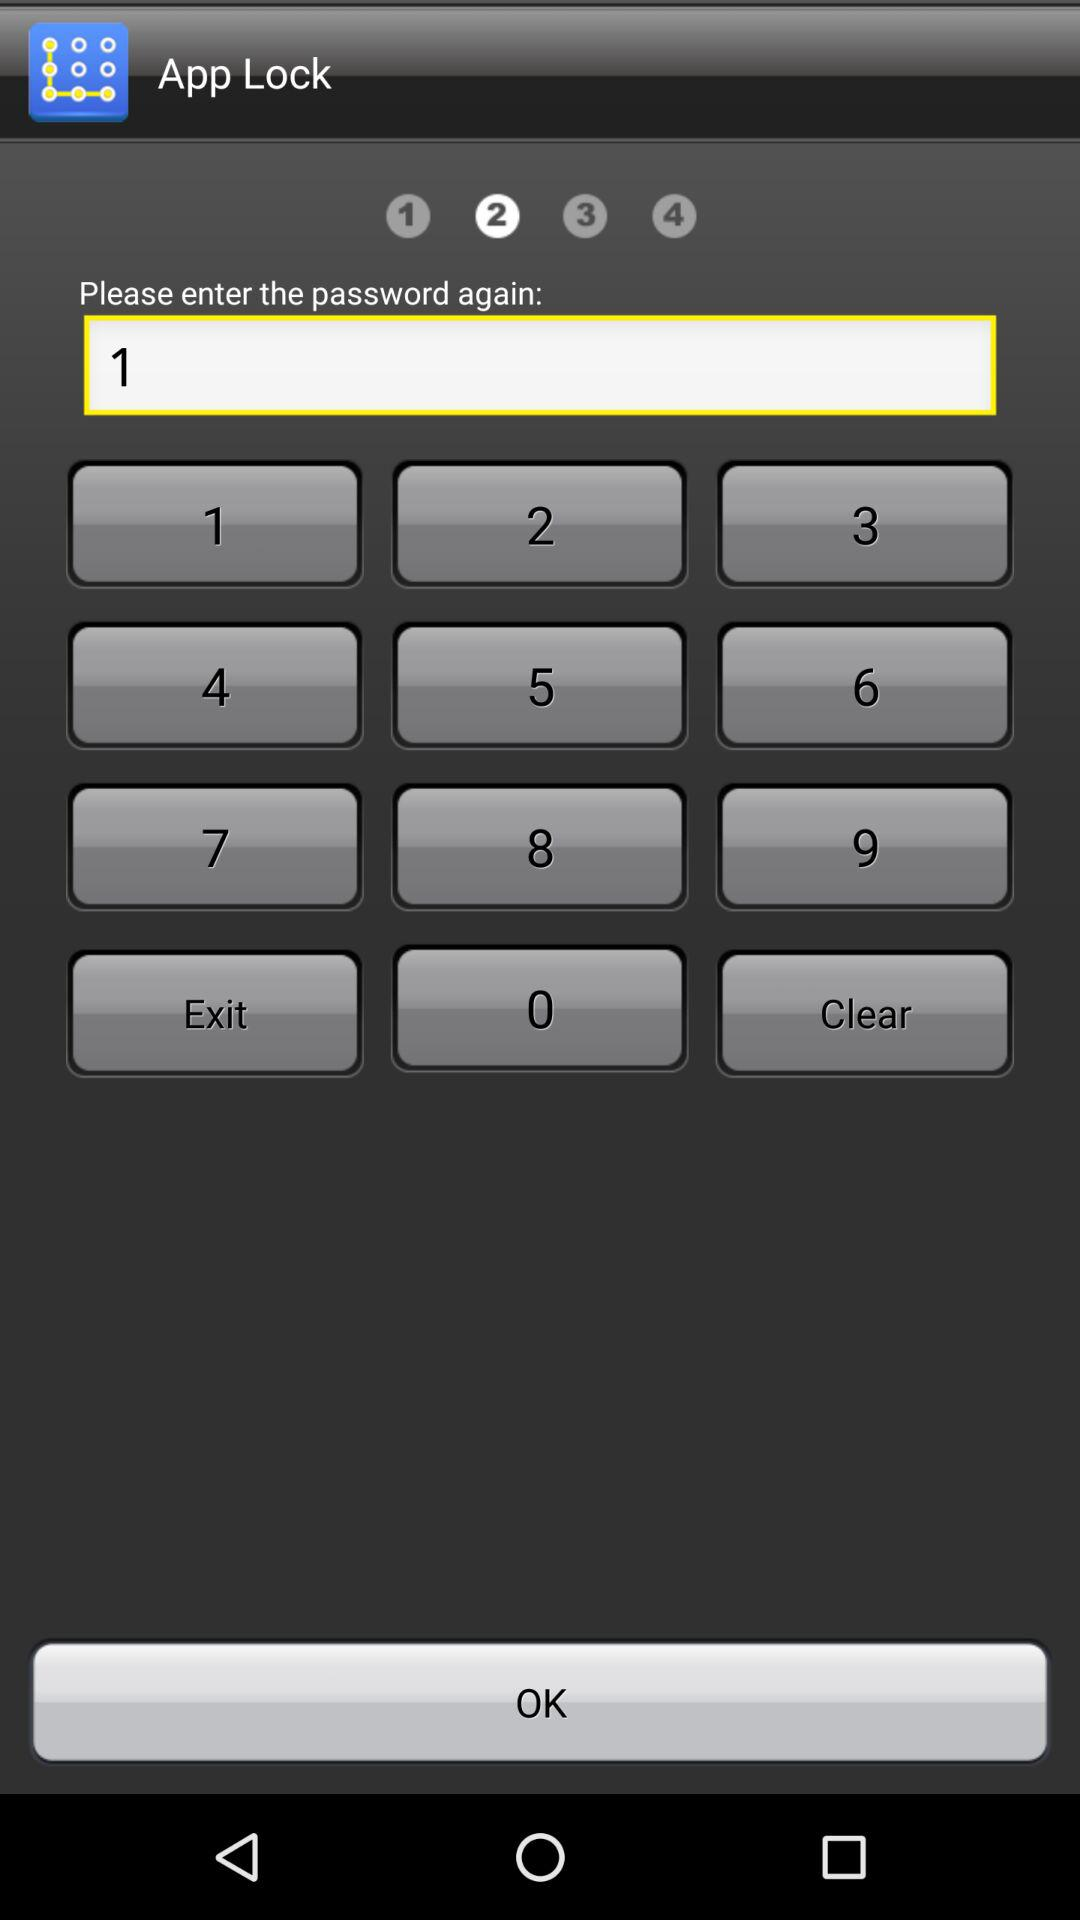What is the application name? The application name is "App Lock". 